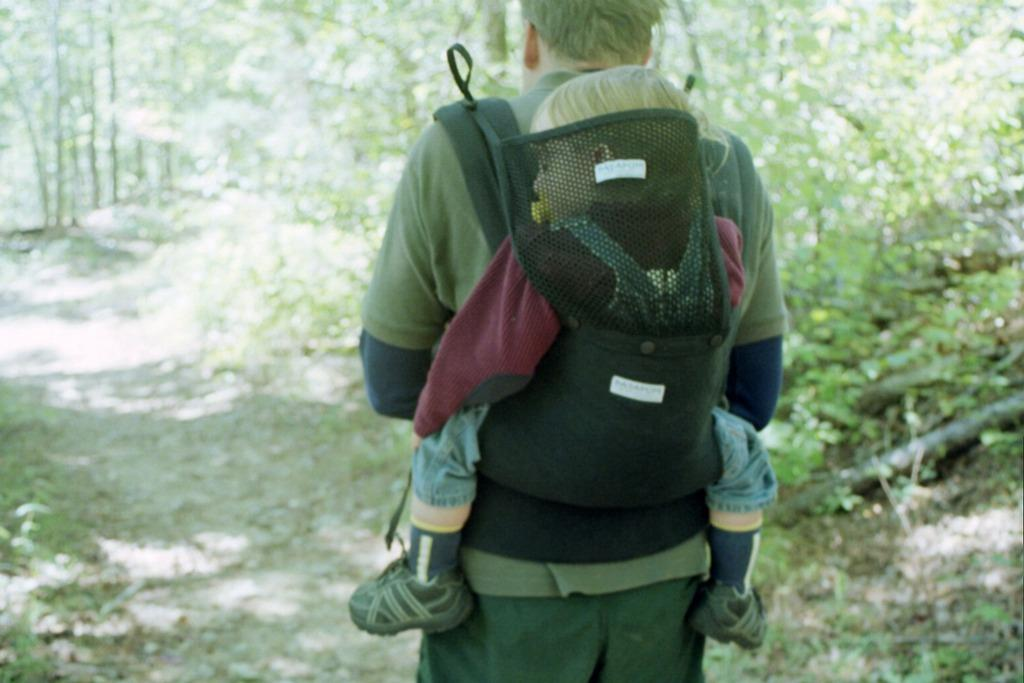Who is present in the image? There is a person and a kid in the image. What can be seen in the background of the image? There are trees, plants, the ground, and other objects in the background of the image. What type of toothbrush is the kid using in the image? There is no toothbrush present in the image. How does the nerve affect the person's expression in the image? There is no mention of a nerve or any expression in the image. 